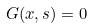Convert formula to latex. <formula><loc_0><loc_0><loc_500><loc_500>G ( x , s ) = 0</formula> 